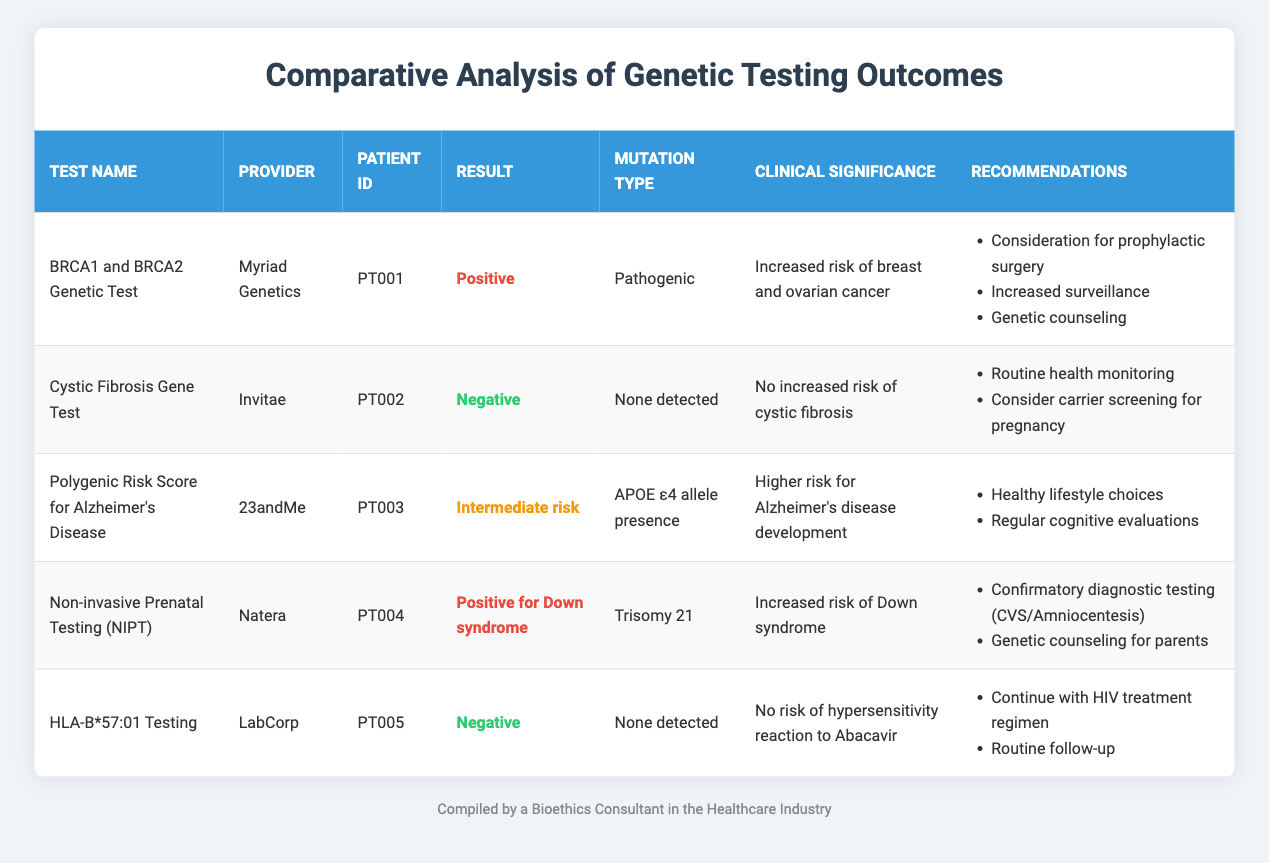What is the result of the BRCA1 and BRCA2 Genetic Test? The table indicates that the result of the BRCA1 and BRCA2 Genetic Test is "Positive".
Answer: Positive Which patient received the Non-invasive Prenatal Testing? Referring to the table, we can see that the patient with Patient ID "PT004" received the Non-invasive Prenatal Testing.
Answer: PT004 How many tests have a clinical significance indicating increased risk of a disease? By reviewing the table, the BRCA1 and BRCA2 Genetic Test and Non-invasive Prenatal Testing both indicate increased risk (breast and ovarian cancer, Down syndrome respectively), so there are two tests.
Answer: 2 Is there any genetic test that shows a negative result for a mutation? The Cystic Fibrosis Gene Test and HLA-B*57:01 Testing both show a negative result, indicating no mutation detected. Hence, the statement is true.
Answer: Yes What recommendations are suggested for the Polygenic Risk Score for Alzheimer’s Disease test? The table lists the recommendations for this test as: "Healthy lifestyle choices" and "Regular cognitive evaluations".
Answer: Healthy lifestyle choices, Regular cognitive evaluations What is the mutation type for the Cystic Fibrosis Gene Test? According to the table, the mutation type for the Cystic Fibrosis Gene Test is "None detected".
Answer: None detected Which test indicates a pathogenic mutation, and what is the result? The table shows that the BRCA1 and BRCA2 Genetic Test indicates a pathogenic mutation with the result being "Positive".
Answer: BRCA1 and BRCA2 Genetic Test, Positive What are the recommended actions following a positive result for Down syndrome in Non-invasive Prenatal Testing? The recommendations are "Confirmatory diagnostic testing (CVS/Amniocentesis)" and "Genetic counseling for parents".
Answer: Confirmatory diagnostic testing, Genetic counseling for parents For which test(s) is genetic counseling recommended? From the table, genetic counseling is recommended for the BRCA1 and BRCA2 Genetic Test as well as the Non-invasive Prenatal Testing. Thus, there are two tests.
Answer: 2 